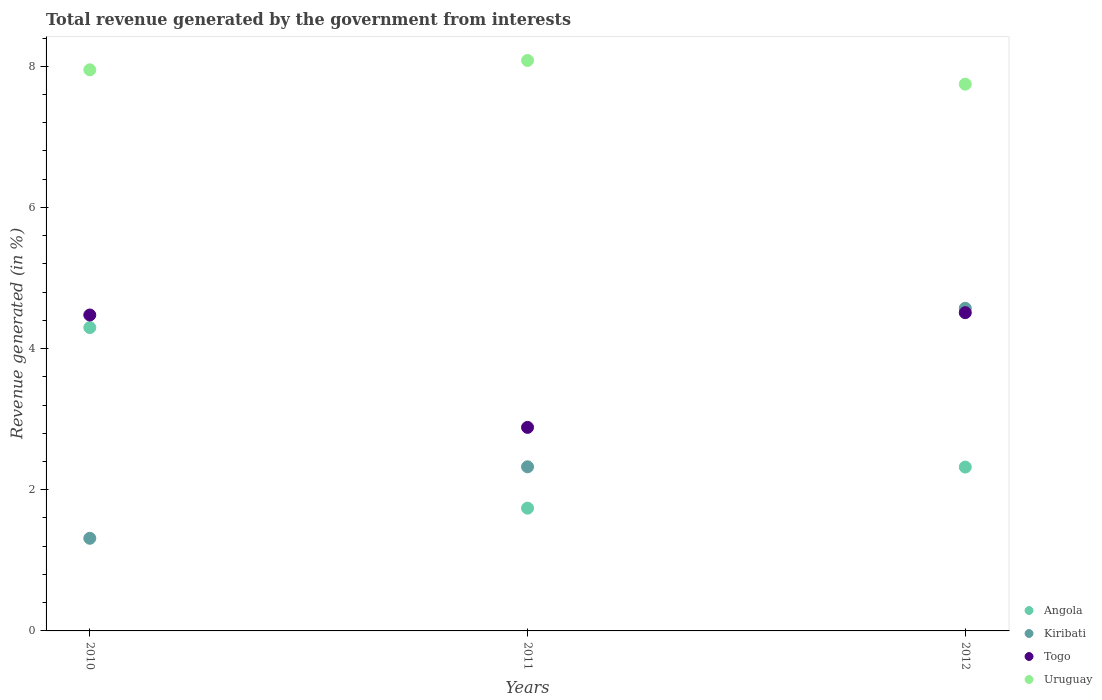How many different coloured dotlines are there?
Give a very brief answer. 4. Is the number of dotlines equal to the number of legend labels?
Make the answer very short. Yes. What is the total revenue generated in Angola in 2012?
Provide a short and direct response. 2.32. Across all years, what is the maximum total revenue generated in Angola?
Keep it short and to the point. 4.3. Across all years, what is the minimum total revenue generated in Angola?
Give a very brief answer. 1.74. What is the total total revenue generated in Kiribati in the graph?
Provide a succinct answer. 8.21. What is the difference between the total revenue generated in Togo in 2010 and that in 2012?
Keep it short and to the point. -0.03. What is the difference between the total revenue generated in Kiribati in 2011 and the total revenue generated in Angola in 2010?
Your response must be concise. -1.97. What is the average total revenue generated in Angola per year?
Make the answer very short. 2.79. In the year 2011, what is the difference between the total revenue generated in Uruguay and total revenue generated in Togo?
Offer a very short reply. 5.2. What is the ratio of the total revenue generated in Kiribati in 2010 to that in 2011?
Keep it short and to the point. 0.56. Is the total revenue generated in Togo in 2011 less than that in 2012?
Offer a terse response. Yes. Is the difference between the total revenue generated in Uruguay in 2011 and 2012 greater than the difference between the total revenue generated in Togo in 2011 and 2012?
Make the answer very short. Yes. What is the difference between the highest and the second highest total revenue generated in Uruguay?
Ensure brevity in your answer.  0.13. What is the difference between the highest and the lowest total revenue generated in Togo?
Your answer should be very brief. 1.63. Is the sum of the total revenue generated in Kiribati in 2010 and 2011 greater than the maximum total revenue generated in Angola across all years?
Provide a short and direct response. No. Is the total revenue generated in Uruguay strictly greater than the total revenue generated in Togo over the years?
Make the answer very short. Yes. What is the difference between two consecutive major ticks on the Y-axis?
Give a very brief answer. 2. Are the values on the major ticks of Y-axis written in scientific E-notation?
Provide a short and direct response. No. Does the graph contain grids?
Your answer should be very brief. No. Where does the legend appear in the graph?
Give a very brief answer. Bottom right. What is the title of the graph?
Make the answer very short. Total revenue generated by the government from interests. Does "Liberia" appear as one of the legend labels in the graph?
Your answer should be compact. No. What is the label or title of the X-axis?
Your answer should be compact. Years. What is the label or title of the Y-axis?
Provide a succinct answer. Revenue generated (in %). What is the Revenue generated (in %) in Angola in 2010?
Offer a terse response. 4.3. What is the Revenue generated (in %) in Kiribati in 2010?
Give a very brief answer. 1.31. What is the Revenue generated (in %) of Togo in 2010?
Provide a succinct answer. 4.48. What is the Revenue generated (in %) in Uruguay in 2010?
Make the answer very short. 7.95. What is the Revenue generated (in %) in Angola in 2011?
Give a very brief answer. 1.74. What is the Revenue generated (in %) in Kiribati in 2011?
Your answer should be very brief. 2.33. What is the Revenue generated (in %) of Togo in 2011?
Your answer should be very brief. 2.88. What is the Revenue generated (in %) in Uruguay in 2011?
Keep it short and to the point. 8.08. What is the Revenue generated (in %) in Angola in 2012?
Give a very brief answer. 2.32. What is the Revenue generated (in %) of Kiribati in 2012?
Offer a terse response. 4.57. What is the Revenue generated (in %) of Togo in 2012?
Your answer should be compact. 4.51. What is the Revenue generated (in %) of Uruguay in 2012?
Offer a terse response. 7.75. Across all years, what is the maximum Revenue generated (in %) in Angola?
Provide a succinct answer. 4.3. Across all years, what is the maximum Revenue generated (in %) of Kiribati?
Make the answer very short. 4.57. Across all years, what is the maximum Revenue generated (in %) in Togo?
Give a very brief answer. 4.51. Across all years, what is the maximum Revenue generated (in %) in Uruguay?
Keep it short and to the point. 8.08. Across all years, what is the minimum Revenue generated (in %) of Angola?
Offer a terse response. 1.74. Across all years, what is the minimum Revenue generated (in %) in Kiribati?
Keep it short and to the point. 1.31. Across all years, what is the minimum Revenue generated (in %) in Togo?
Your response must be concise. 2.88. Across all years, what is the minimum Revenue generated (in %) of Uruguay?
Your answer should be compact. 7.75. What is the total Revenue generated (in %) in Angola in the graph?
Provide a succinct answer. 8.36. What is the total Revenue generated (in %) of Kiribati in the graph?
Give a very brief answer. 8.21. What is the total Revenue generated (in %) of Togo in the graph?
Provide a short and direct response. 11.87. What is the total Revenue generated (in %) in Uruguay in the graph?
Make the answer very short. 23.78. What is the difference between the Revenue generated (in %) in Angola in 2010 and that in 2011?
Your answer should be very brief. 2.56. What is the difference between the Revenue generated (in %) in Kiribati in 2010 and that in 2011?
Make the answer very short. -1.01. What is the difference between the Revenue generated (in %) of Togo in 2010 and that in 2011?
Provide a short and direct response. 1.59. What is the difference between the Revenue generated (in %) in Uruguay in 2010 and that in 2011?
Ensure brevity in your answer.  -0.13. What is the difference between the Revenue generated (in %) in Angola in 2010 and that in 2012?
Make the answer very short. 1.98. What is the difference between the Revenue generated (in %) in Kiribati in 2010 and that in 2012?
Your response must be concise. -3.26. What is the difference between the Revenue generated (in %) in Togo in 2010 and that in 2012?
Provide a succinct answer. -0.03. What is the difference between the Revenue generated (in %) of Uruguay in 2010 and that in 2012?
Offer a very short reply. 0.2. What is the difference between the Revenue generated (in %) of Angola in 2011 and that in 2012?
Your answer should be compact. -0.58. What is the difference between the Revenue generated (in %) of Kiribati in 2011 and that in 2012?
Keep it short and to the point. -2.25. What is the difference between the Revenue generated (in %) in Togo in 2011 and that in 2012?
Give a very brief answer. -1.63. What is the difference between the Revenue generated (in %) of Uruguay in 2011 and that in 2012?
Your answer should be very brief. 0.34. What is the difference between the Revenue generated (in %) in Angola in 2010 and the Revenue generated (in %) in Kiribati in 2011?
Provide a short and direct response. 1.97. What is the difference between the Revenue generated (in %) in Angola in 2010 and the Revenue generated (in %) in Togo in 2011?
Your answer should be very brief. 1.41. What is the difference between the Revenue generated (in %) of Angola in 2010 and the Revenue generated (in %) of Uruguay in 2011?
Ensure brevity in your answer.  -3.78. What is the difference between the Revenue generated (in %) in Kiribati in 2010 and the Revenue generated (in %) in Togo in 2011?
Provide a succinct answer. -1.57. What is the difference between the Revenue generated (in %) in Kiribati in 2010 and the Revenue generated (in %) in Uruguay in 2011?
Your answer should be very brief. -6.77. What is the difference between the Revenue generated (in %) in Togo in 2010 and the Revenue generated (in %) in Uruguay in 2011?
Provide a short and direct response. -3.61. What is the difference between the Revenue generated (in %) of Angola in 2010 and the Revenue generated (in %) of Kiribati in 2012?
Give a very brief answer. -0.27. What is the difference between the Revenue generated (in %) in Angola in 2010 and the Revenue generated (in %) in Togo in 2012?
Your answer should be compact. -0.21. What is the difference between the Revenue generated (in %) of Angola in 2010 and the Revenue generated (in %) of Uruguay in 2012?
Give a very brief answer. -3.45. What is the difference between the Revenue generated (in %) in Kiribati in 2010 and the Revenue generated (in %) in Togo in 2012?
Offer a terse response. -3.2. What is the difference between the Revenue generated (in %) in Kiribati in 2010 and the Revenue generated (in %) in Uruguay in 2012?
Make the answer very short. -6.43. What is the difference between the Revenue generated (in %) in Togo in 2010 and the Revenue generated (in %) in Uruguay in 2012?
Provide a short and direct response. -3.27. What is the difference between the Revenue generated (in %) in Angola in 2011 and the Revenue generated (in %) in Kiribati in 2012?
Offer a very short reply. -2.83. What is the difference between the Revenue generated (in %) in Angola in 2011 and the Revenue generated (in %) in Togo in 2012?
Offer a terse response. -2.77. What is the difference between the Revenue generated (in %) of Angola in 2011 and the Revenue generated (in %) of Uruguay in 2012?
Offer a very short reply. -6.01. What is the difference between the Revenue generated (in %) of Kiribati in 2011 and the Revenue generated (in %) of Togo in 2012?
Ensure brevity in your answer.  -2.18. What is the difference between the Revenue generated (in %) of Kiribati in 2011 and the Revenue generated (in %) of Uruguay in 2012?
Give a very brief answer. -5.42. What is the difference between the Revenue generated (in %) of Togo in 2011 and the Revenue generated (in %) of Uruguay in 2012?
Make the answer very short. -4.86. What is the average Revenue generated (in %) in Angola per year?
Your response must be concise. 2.79. What is the average Revenue generated (in %) in Kiribati per year?
Your response must be concise. 2.74. What is the average Revenue generated (in %) of Togo per year?
Give a very brief answer. 3.96. What is the average Revenue generated (in %) in Uruguay per year?
Offer a terse response. 7.93. In the year 2010, what is the difference between the Revenue generated (in %) in Angola and Revenue generated (in %) in Kiribati?
Your response must be concise. 2.99. In the year 2010, what is the difference between the Revenue generated (in %) in Angola and Revenue generated (in %) in Togo?
Your answer should be very brief. -0.18. In the year 2010, what is the difference between the Revenue generated (in %) in Angola and Revenue generated (in %) in Uruguay?
Ensure brevity in your answer.  -3.65. In the year 2010, what is the difference between the Revenue generated (in %) in Kiribati and Revenue generated (in %) in Togo?
Provide a short and direct response. -3.16. In the year 2010, what is the difference between the Revenue generated (in %) of Kiribati and Revenue generated (in %) of Uruguay?
Ensure brevity in your answer.  -6.64. In the year 2010, what is the difference between the Revenue generated (in %) of Togo and Revenue generated (in %) of Uruguay?
Your answer should be very brief. -3.47. In the year 2011, what is the difference between the Revenue generated (in %) in Angola and Revenue generated (in %) in Kiribati?
Your answer should be very brief. -0.59. In the year 2011, what is the difference between the Revenue generated (in %) in Angola and Revenue generated (in %) in Togo?
Your answer should be compact. -1.14. In the year 2011, what is the difference between the Revenue generated (in %) of Angola and Revenue generated (in %) of Uruguay?
Provide a succinct answer. -6.34. In the year 2011, what is the difference between the Revenue generated (in %) of Kiribati and Revenue generated (in %) of Togo?
Provide a short and direct response. -0.56. In the year 2011, what is the difference between the Revenue generated (in %) of Kiribati and Revenue generated (in %) of Uruguay?
Ensure brevity in your answer.  -5.76. In the year 2011, what is the difference between the Revenue generated (in %) of Togo and Revenue generated (in %) of Uruguay?
Offer a terse response. -5.2. In the year 2012, what is the difference between the Revenue generated (in %) of Angola and Revenue generated (in %) of Kiribati?
Give a very brief answer. -2.25. In the year 2012, what is the difference between the Revenue generated (in %) in Angola and Revenue generated (in %) in Togo?
Offer a terse response. -2.19. In the year 2012, what is the difference between the Revenue generated (in %) in Angola and Revenue generated (in %) in Uruguay?
Your answer should be very brief. -5.42. In the year 2012, what is the difference between the Revenue generated (in %) of Kiribati and Revenue generated (in %) of Togo?
Provide a succinct answer. 0.06. In the year 2012, what is the difference between the Revenue generated (in %) in Kiribati and Revenue generated (in %) in Uruguay?
Ensure brevity in your answer.  -3.18. In the year 2012, what is the difference between the Revenue generated (in %) in Togo and Revenue generated (in %) in Uruguay?
Provide a short and direct response. -3.24. What is the ratio of the Revenue generated (in %) of Angola in 2010 to that in 2011?
Your answer should be very brief. 2.47. What is the ratio of the Revenue generated (in %) of Kiribati in 2010 to that in 2011?
Your answer should be very brief. 0.56. What is the ratio of the Revenue generated (in %) in Togo in 2010 to that in 2011?
Your answer should be compact. 1.55. What is the ratio of the Revenue generated (in %) in Uruguay in 2010 to that in 2011?
Ensure brevity in your answer.  0.98. What is the ratio of the Revenue generated (in %) in Angola in 2010 to that in 2012?
Keep it short and to the point. 1.85. What is the ratio of the Revenue generated (in %) in Kiribati in 2010 to that in 2012?
Your answer should be very brief. 0.29. What is the ratio of the Revenue generated (in %) of Togo in 2010 to that in 2012?
Give a very brief answer. 0.99. What is the ratio of the Revenue generated (in %) of Uruguay in 2010 to that in 2012?
Make the answer very short. 1.03. What is the ratio of the Revenue generated (in %) of Angola in 2011 to that in 2012?
Your response must be concise. 0.75. What is the ratio of the Revenue generated (in %) in Kiribati in 2011 to that in 2012?
Offer a very short reply. 0.51. What is the ratio of the Revenue generated (in %) of Togo in 2011 to that in 2012?
Make the answer very short. 0.64. What is the ratio of the Revenue generated (in %) of Uruguay in 2011 to that in 2012?
Provide a short and direct response. 1.04. What is the difference between the highest and the second highest Revenue generated (in %) of Angola?
Give a very brief answer. 1.98. What is the difference between the highest and the second highest Revenue generated (in %) in Kiribati?
Give a very brief answer. 2.25. What is the difference between the highest and the second highest Revenue generated (in %) of Togo?
Offer a very short reply. 0.03. What is the difference between the highest and the second highest Revenue generated (in %) in Uruguay?
Keep it short and to the point. 0.13. What is the difference between the highest and the lowest Revenue generated (in %) of Angola?
Offer a terse response. 2.56. What is the difference between the highest and the lowest Revenue generated (in %) of Kiribati?
Your answer should be very brief. 3.26. What is the difference between the highest and the lowest Revenue generated (in %) in Togo?
Ensure brevity in your answer.  1.63. What is the difference between the highest and the lowest Revenue generated (in %) of Uruguay?
Give a very brief answer. 0.34. 